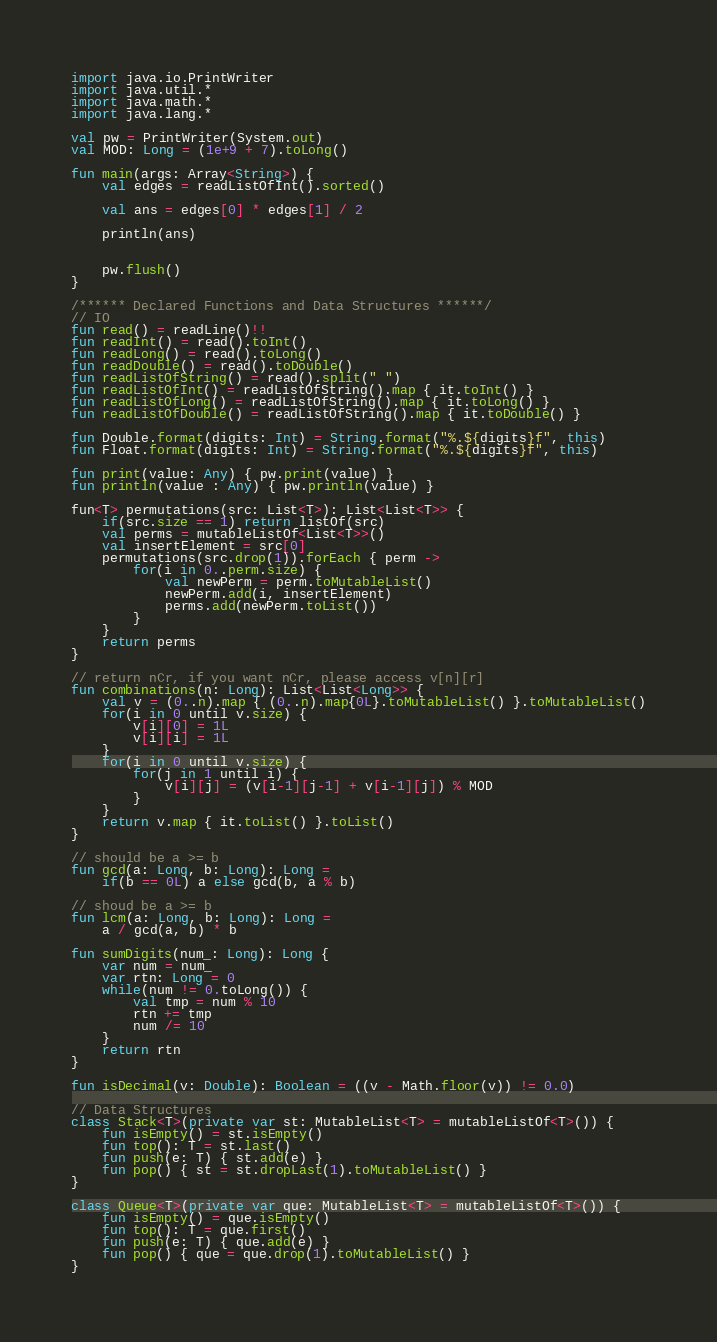Convert code to text. <code><loc_0><loc_0><loc_500><loc_500><_Kotlin_>import java.io.PrintWriter
import java.util.*
import java.math.*
import java.lang.*

val pw = PrintWriter(System.out)
val MOD: Long = (1e+9 + 7).toLong()

fun main(args: Array<String>) {
    val edges = readListOfInt().sorted()

    val ans = edges[0] * edges[1] / 2

    println(ans)


    pw.flush()
}

/****** Declared Functions and Data Structures ******/
// IO
fun read() = readLine()!!
fun readInt() = read().toInt()
fun readLong() = read().toLong()
fun readDouble() = read().toDouble()
fun readListOfString() = read().split(" ")
fun readListOfInt() = readListOfString().map { it.toInt() }
fun readListOfLong() = readListOfString().map { it.toLong() }
fun readListOfDouble() = readListOfString().map { it.toDouble() }

fun Double.format(digits: Int) = String.format("%.${digits}f", this)
fun Float.format(digits: Int) = String.format("%.${digits}f", this)

fun print(value: Any) { pw.print(value) }
fun println(value : Any) { pw.println(value) }

fun<T> permutations(src: List<T>): List<List<T>> {
    if(src.size == 1) return listOf(src)
    val perms = mutableListOf<List<T>>()
    val insertElement = src[0]
    permutations(src.drop(1)).forEach { perm ->
        for(i in 0..perm.size) {
            val newPerm = perm.toMutableList()
            newPerm.add(i, insertElement)
            perms.add(newPerm.toList())
        }
    }
    return perms
}

// return nCr, if you want nCr, please access v[n][r]
fun combinations(n: Long): List<List<Long>> {
    val v = (0..n).map { (0..n).map{0L}.toMutableList() }.toMutableList()
    for(i in 0 until v.size) {
        v[i][0] = 1L
        v[i][i] = 1L
    }
    for(i in 0 until v.size) {
        for(j in 1 until i) {
            v[i][j] = (v[i-1][j-1] + v[i-1][j]) % MOD
        }
    }
    return v.map { it.toList() }.toList()
}

// should be a >= b
fun gcd(a: Long, b: Long): Long = 
    if(b == 0L) a else gcd(b, a % b)

// shoud be a >= b
fun lcm(a: Long, b: Long): Long = 
    a / gcd(a, b) * b

fun sumDigits(num_: Long): Long {
    var num = num_
    var rtn: Long = 0
    while(num != 0.toLong()) {
        val tmp = num % 10
        rtn += tmp
        num /= 10
    }
    return rtn
}

fun isDecimal(v: Double): Boolean = ((v - Math.floor(v)) != 0.0)

// Data Structures
class Stack<T>(private var st: MutableList<T> = mutableListOf<T>()) {
    fun isEmpty() = st.isEmpty()
    fun top(): T = st.last()
    fun push(e: T) { st.add(e) }
    fun pop() { st = st.dropLast(1).toMutableList() }
}

class Queue<T>(private var que: MutableList<T> = mutableListOf<T>()) {
    fun isEmpty() = que.isEmpty()
    fun top(): T = que.first()
    fun push(e: T) { que.add(e) }
    fun pop() { que = que.drop(1).toMutableList() }
}
</code> 